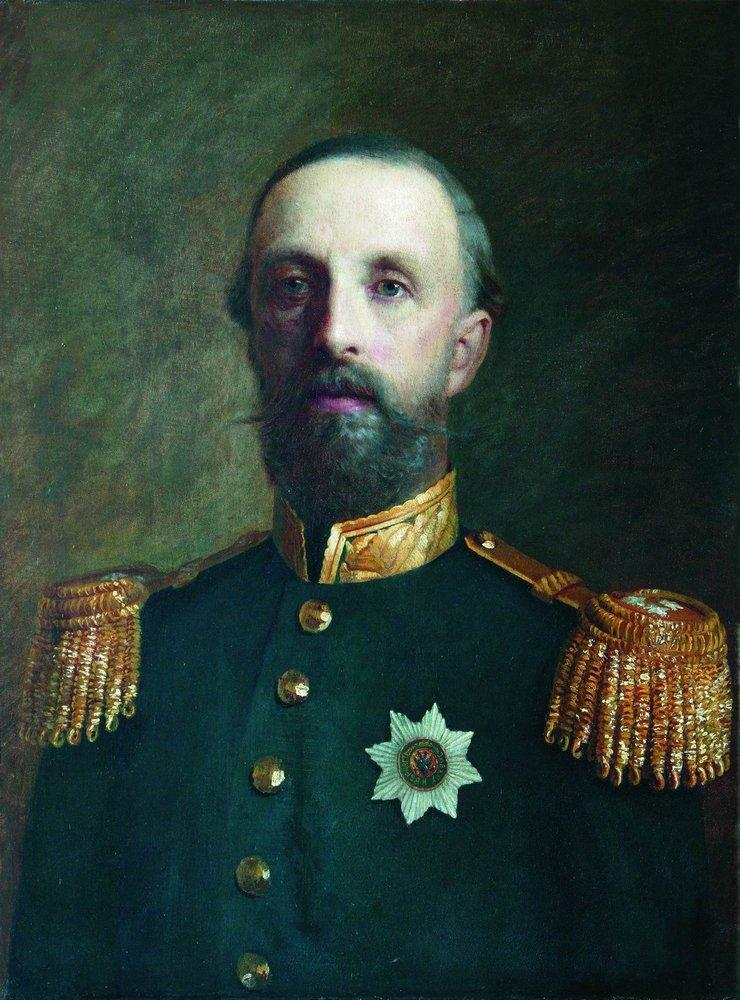How might this painting have been viewed by the public when it was first unveiled? When this painting was first unveiled, it likely commanded great attention and respect from the public. Those who viewed it would have seen not just a portrait, but a symbol of national pride. The realistic style and the details of the uniform would have been recognized as marks of a distinguished military leader, eliciting admiration and reverence. Many would have felt a deep sense of gratitude and respect for the sacrifices he made, and this in turn would have strengthened their own nationalistic sentiments. For some, it might have served as a hopeful reminder of noble leadership during turbulent times. It’s also possible the portrait inspired younger generations to emulate his values, encouraging them to join the military and serve their country with similar dedication and honor. The image would have embodied the ideals of courage, integrity, and sacrifice, serving as a touchstone for the values that the society held dear at the time. 